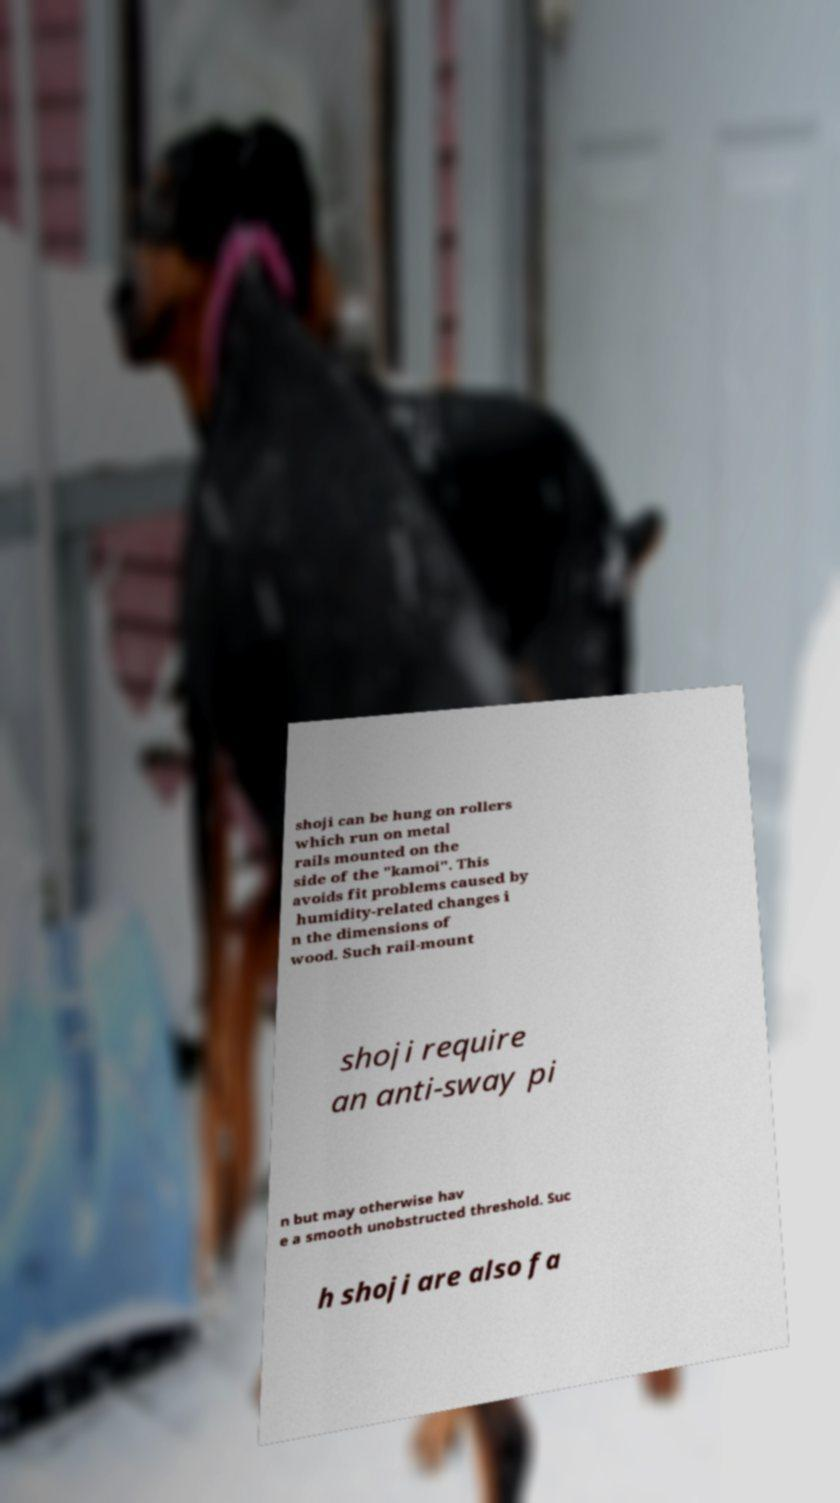Please identify and transcribe the text found in this image. shoji can be hung on rollers which run on metal rails mounted on the side of the "kamoi". This avoids fit problems caused by humidity-related changes i n the dimensions of wood. Such rail-mount shoji require an anti-sway pi n but may otherwise hav e a smooth unobstructed threshold. Suc h shoji are also fa 